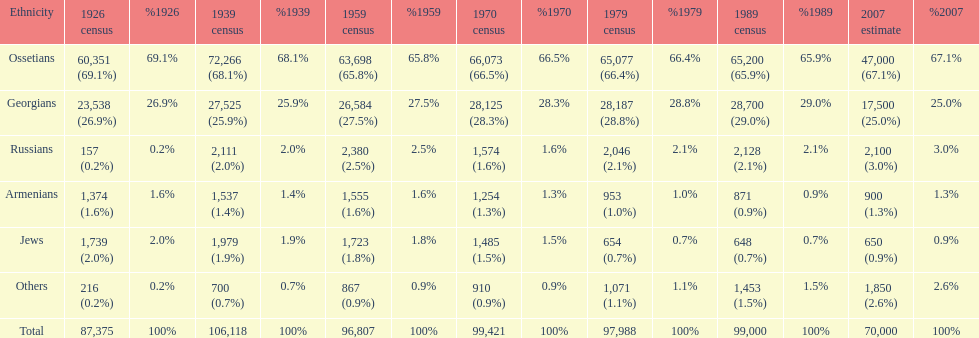How many russians lived in south ossetia in 1970? 1,574. 